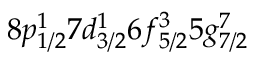Convert formula to latex. <formula><loc_0><loc_0><loc_500><loc_500>8 p _ { 1 / 2 } ^ { 1 } 7 d _ { 3 / 2 } ^ { 1 } 6 f _ { 5 / 2 } ^ { 3 } 5 g _ { 7 / 2 } ^ { 7 }</formula> 